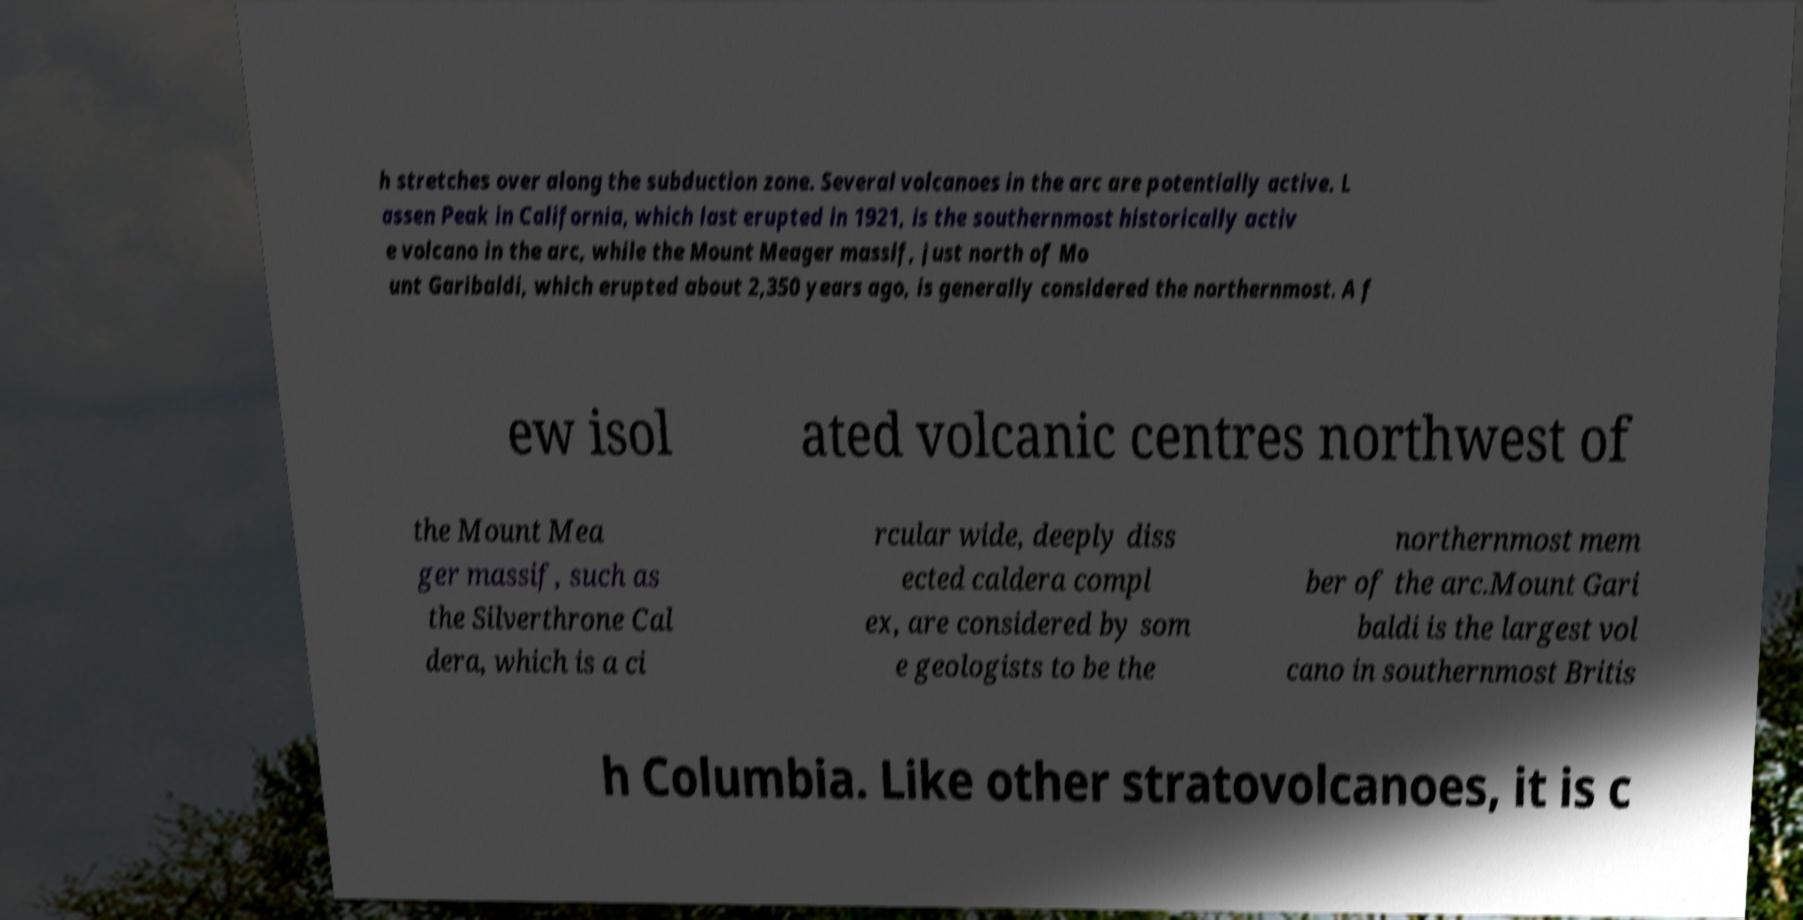I need the written content from this picture converted into text. Can you do that? h stretches over along the subduction zone. Several volcanoes in the arc are potentially active. L assen Peak in California, which last erupted in 1921, is the southernmost historically activ e volcano in the arc, while the Mount Meager massif, just north of Mo unt Garibaldi, which erupted about 2,350 years ago, is generally considered the northernmost. A f ew isol ated volcanic centres northwest of the Mount Mea ger massif, such as the Silverthrone Cal dera, which is a ci rcular wide, deeply diss ected caldera compl ex, are considered by som e geologists to be the northernmost mem ber of the arc.Mount Gari baldi is the largest vol cano in southernmost Britis h Columbia. Like other stratovolcanoes, it is c 